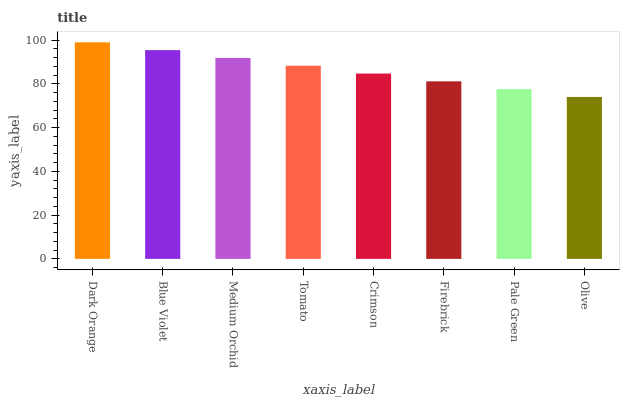Is Blue Violet the minimum?
Answer yes or no. No. Is Blue Violet the maximum?
Answer yes or no. No. Is Dark Orange greater than Blue Violet?
Answer yes or no. Yes. Is Blue Violet less than Dark Orange?
Answer yes or no. Yes. Is Blue Violet greater than Dark Orange?
Answer yes or no. No. Is Dark Orange less than Blue Violet?
Answer yes or no. No. Is Tomato the high median?
Answer yes or no. Yes. Is Crimson the low median?
Answer yes or no. Yes. Is Blue Violet the high median?
Answer yes or no. No. Is Blue Violet the low median?
Answer yes or no. No. 